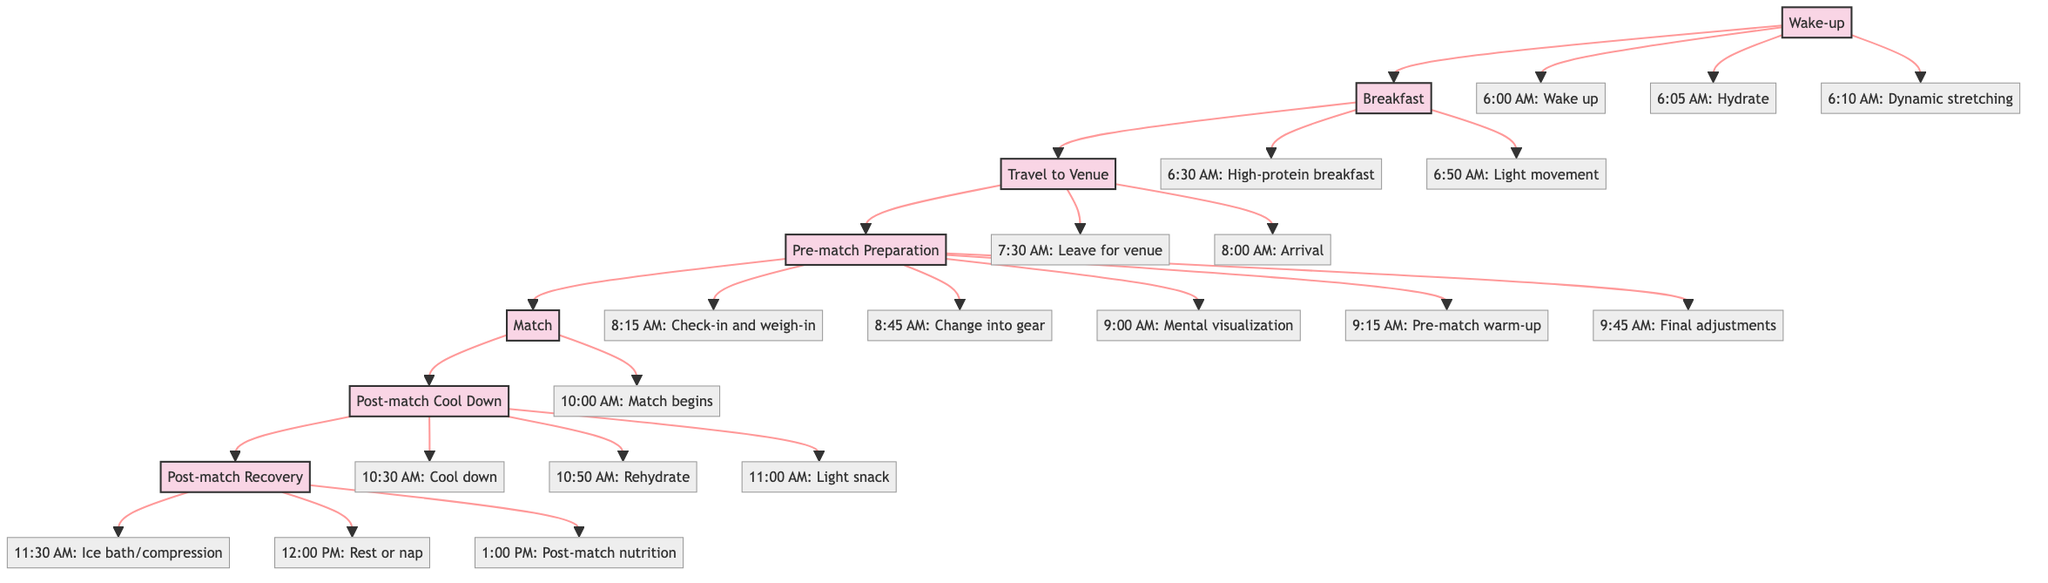What is the first activity after waking up? The diagram shows that after waking up at 6:00 AM, the first activity is to hydrate with 500ml of water at 6:05 AM.
Answer: Hydrate with 500ml of water What time do you change into wrestling gear? According to the diagram, the change into wrestling gear occurs at 8:45 AM, which is part of the pre-match preparation step.
Answer: 8:45 AM How many actions are there in the "Post-match Recovery" step? The diagram indicates that there are three actions listed under the "Post-match Recovery" step: ice bath/compression, rest or nap, and post-match nutrition.
Answer: 3 What action follows the match? Based on the flow chart, the first action after the match is the post-match cool down that begins at 10:30 AM.
Answer: Cool down: Slow jog and static stretching Which step includes mental visualization? The "Pre-match Preparation" step includes the action of mental visualization at 9:00 AM, as detailed in the flow chart.
Answer: Pre-match Preparation What is the time for the match to begin? The diagram clearly states that the match begins at 10:00 AM, which is a specific time designated for that event.
Answer: 10:00 AM What two activities occur after rehydration? After the rehydration at 10:50 AM, the next two activities listed are a light snack at 11:00 AM and post-match recovery procedures beginning at 11:30 AM.
Answer: Light snack and post-match recovery List the last activity in the "Post-match Recovery" step. The last activity outlined in the "Post-match Recovery" section is at 1:00 PM, stated as post-match nutrition which is a balanced meal rich in protein and carbs.
Answer: Post-match nutrition What is the relationship between breakfast and travel to the venue? The diagram indicates a direct sequential relationship where breakfast must be completed before traveling to the venue, as labeled in the flowchart.
Answer: Breakfast must be completed before traveling 